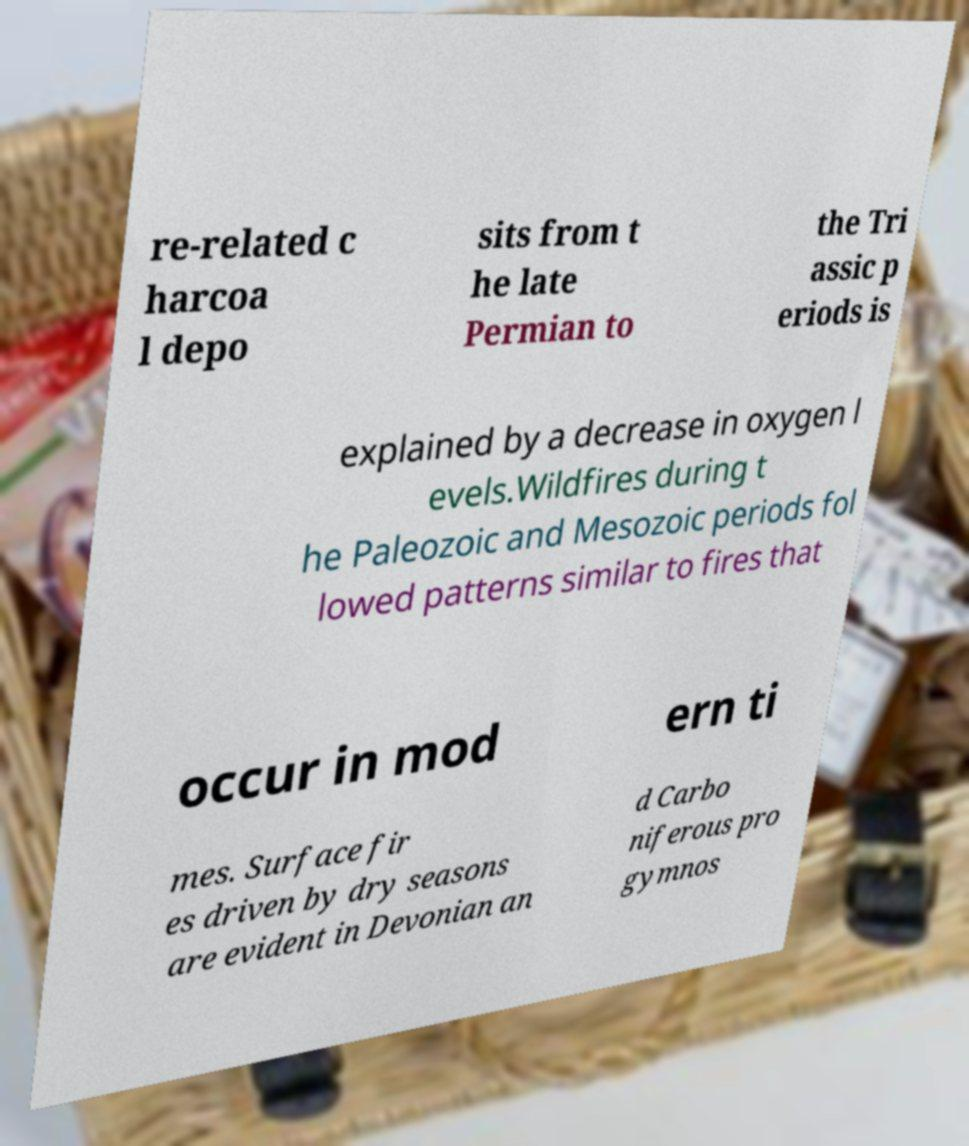Can you read and provide the text displayed in the image?This photo seems to have some interesting text. Can you extract and type it out for me? re-related c harcoa l depo sits from t he late Permian to the Tri assic p eriods is explained by a decrease in oxygen l evels.Wildfires during t he Paleozoic and Mesozoic periods fol lowed patterns similar to fires that occur in mod ern ti mes. Surface fir es driven by dry seasons are evident in Devonian an d Carbo niferous pro gymnos 